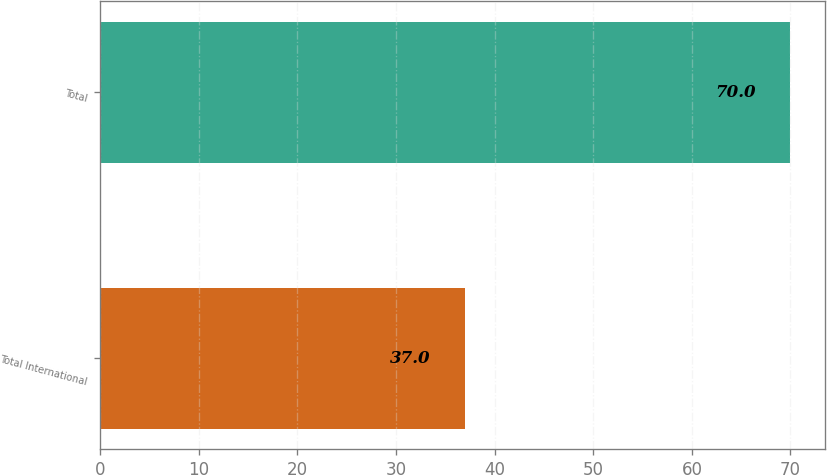Convert chart to OTSL. <chart><loc_0><loc_0><loc_500><loc_500><bar_chart><fcel>Total International<fcel>Total<nl><fcel>37<fcel>70<nl></chart> 